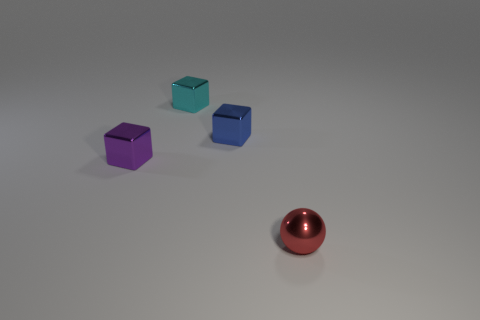Is the number of cyan cubes that are in front of the tiny ball the same as the number of things to the right of the small cyan object?
Your response must be concise. No. Is there any other thing that has the same size as the blue metallic cube?
Your response must be concise. Yes. How many blue objects are small cubes or spheres?
Provide a short and direct response. 1. What number of cyan metal objects are the same size as the red shiny object?
Provide a succinct answer. 1. The tiny metallic block that is both in front of the small cyan shiny cube and to the left of the small blue metal block is what color?
Keep it short and to the point. Purple. Is the number of red objects on the left side of the small purple object greater than the number of blue blocks?
Keep it short and to the point. No. Are any big red cylinders visible?
Ensure brevity in your answer.  No. How many tiny objects are red metallic objects or cyan blocks?
Your response must be concise. 2. Is there any other thing that is the same color as the small ball?
Your answer should be compact. No. What is the shape of the tiny red object that is made of the same material as the small blue block?
Make the answer very short. Sphere. 